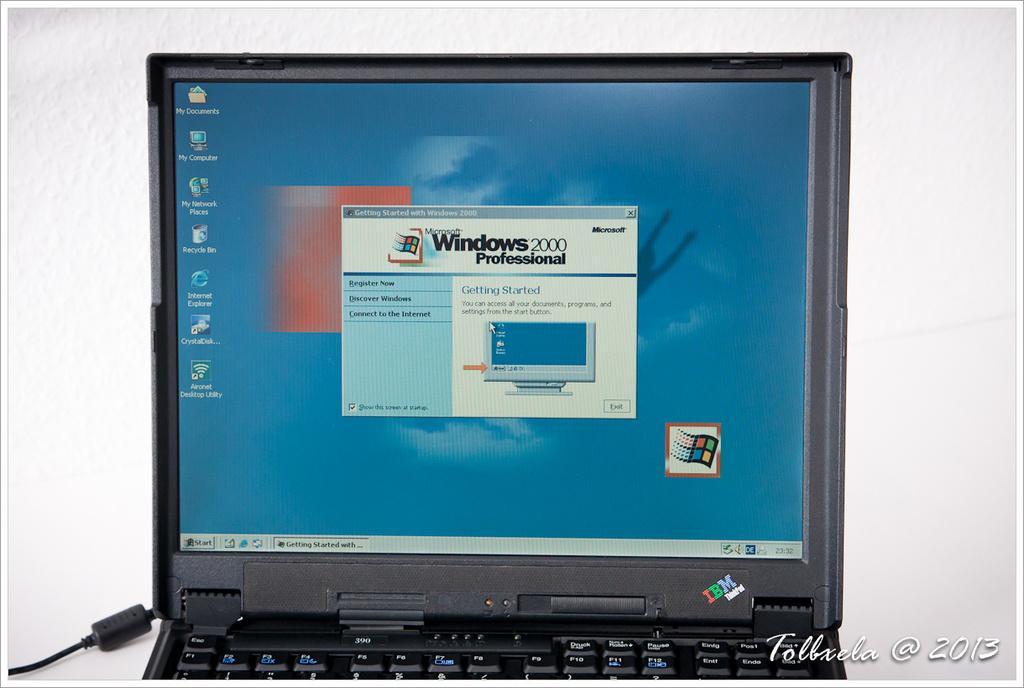Please provide a concise description of this image. There is a picture of a laptop in the middle of this image, and there is a white color wall in the background. There is a watermark at the bottom of this image. 